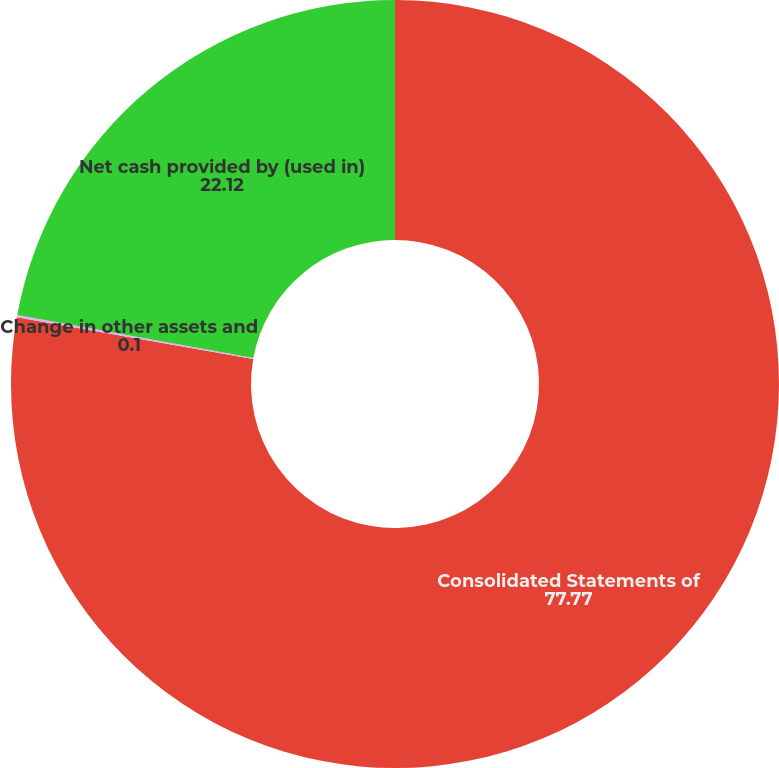Convert chart to OTSL. <chart><loc_0><loc_0><loc_500><loc_500><pie_chart><fcel>Consolidated Statements of<fcel>Change in other assets and<fcel>Net cash provided by (used in)<nl><fcel>77.77%<fcel>0.1%<fcel>22.12%<nl></chart> 